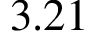Convert formula to latex. <formula><loc_0><loc_0><loc_500><loc_500>3 . 2 1</formula> 